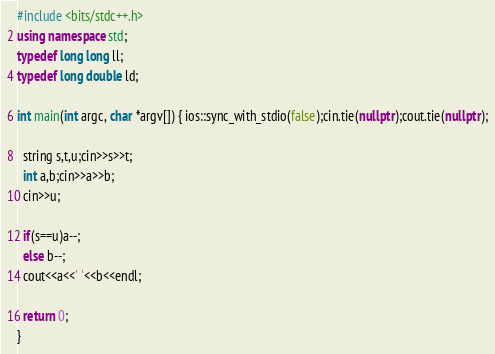Convert code to text. <code><loc_0><loc_0><loc_500><loc_500><_C++_>#include <bits/stdc++.h>
using namespace std;
typedef long long ll;
typedef long double ld;

int main(int argc, char *argv[]) { ios::sync_with_stdio(false);cin.tie(nullptr);cout.tie(nullptr);

  string s,t,u;cin>>s>>t;
  int a,b;cin>>a>>b;
  cin>>u;

  if(s==u)a--;
  else b--;
  cout<<a<<' '<<b<<endl;
  
  return 0;
}
</code> 